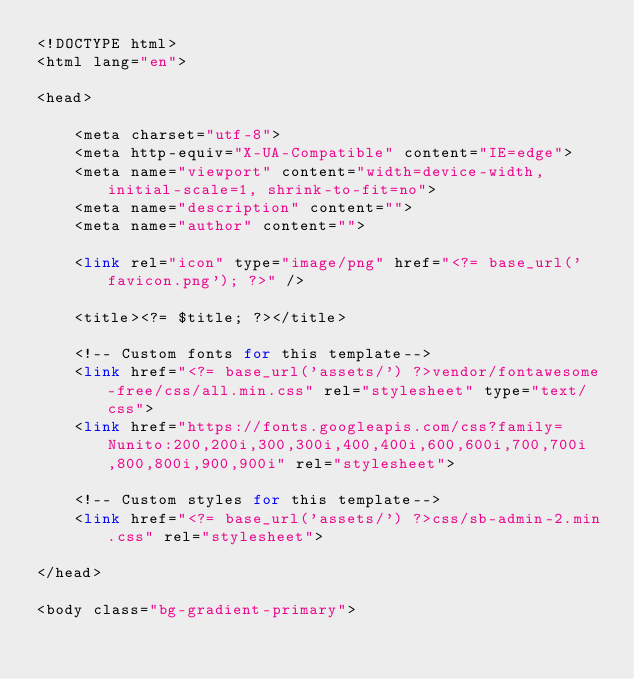<code> <loc_0><loc_0><loc_500><loc_500><_PHP_><!DOCTYPE html>
<html lang="en">

<head>

    <meta charset="utf-8">
    <meta http-equiv="X-UA-Compatible" content="IE=edge">
    <meta name="viewport" content="width=device-width, initial-scale=1, shrink-to-fit=no">
    <meta name="description" content="">
    <meta name="author" content="">

    <link rel="icon" type="image/png" href="<?= base_url('favicon.png'); ?>" />

    <title><?= $title; ?></title>

    <!-- Custom fonts for this template-->
    <link href="<?= base_url('assets/') ?>vendor/fontawesome-free/css/all.min.css" rel="stylesheet" type="text/css">
    <link href="https://fonts.googleapis.com/css?family=Nunito:200,200i,300,300i,400,400i,600,600i,700,700i,800,800i,900,900i" rel="stylesheet">

    <!-- Custom styles for this template-->
    <link href="<?= base_url('assets/') ?>css/sb-admin-2.min.css" rel="stylesheet">

</head>

<body class="bg-gradient-primary"></code> 